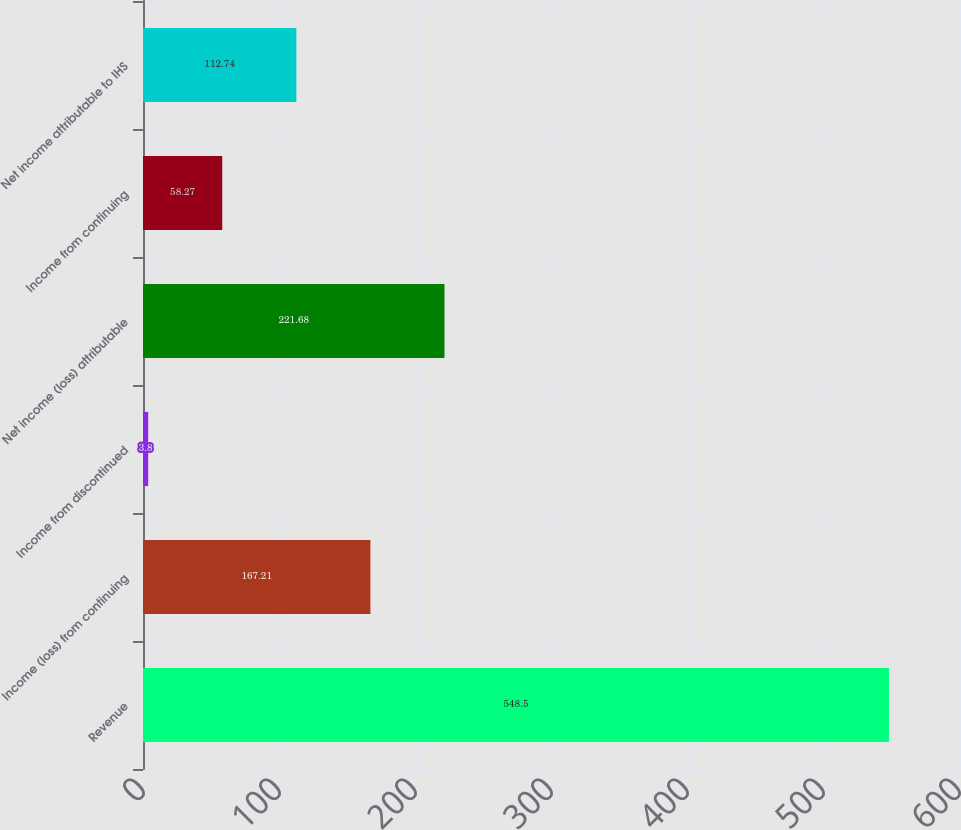Convert chart. <chart><loc_0><loc_0><loc_500><loc_500><bar_chart><fcel>Revenue<fcel>Income (loss) from continuing<fcel>Income from discontinued<fcel>Net income (loss) attributable<fcel>Income from continuing<fcel>Net income attributable to IHS<nl><fcel>548.5<fcel>167.21<fcel>3.8<fcel>221.68<fcel>58.27<fcel>112.74<nl></chart> 